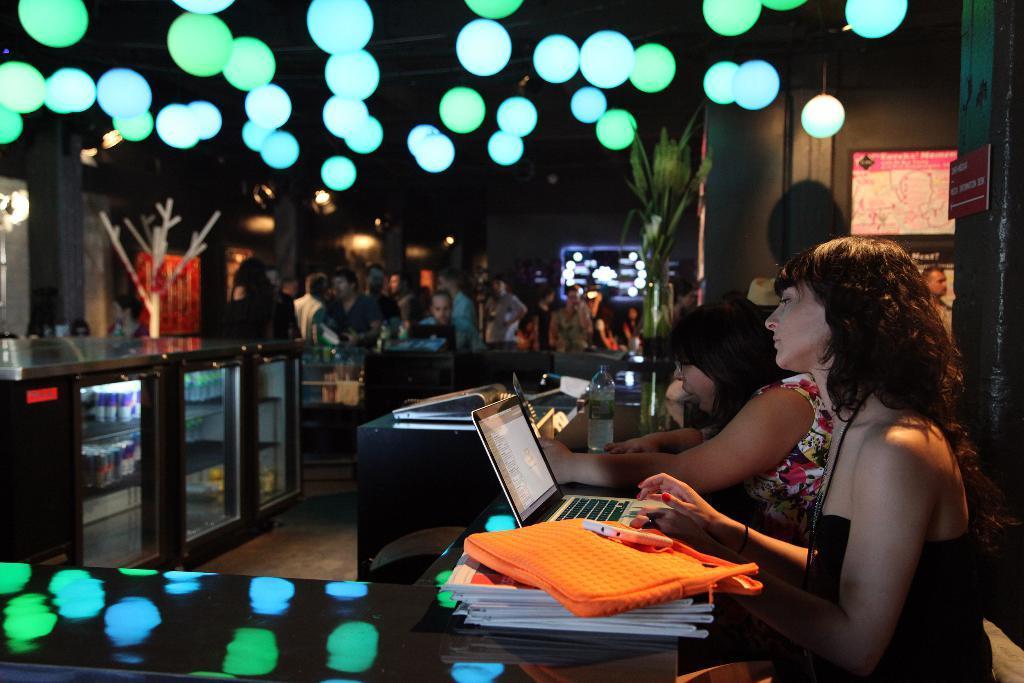In one or two sentences, can you explain what this image depicts? In this image, we can see laptops, books, a bag and some other objects on the stands and we can see people and some are sitting. In the background, there are lights and we can see balloons, boards and plants. 